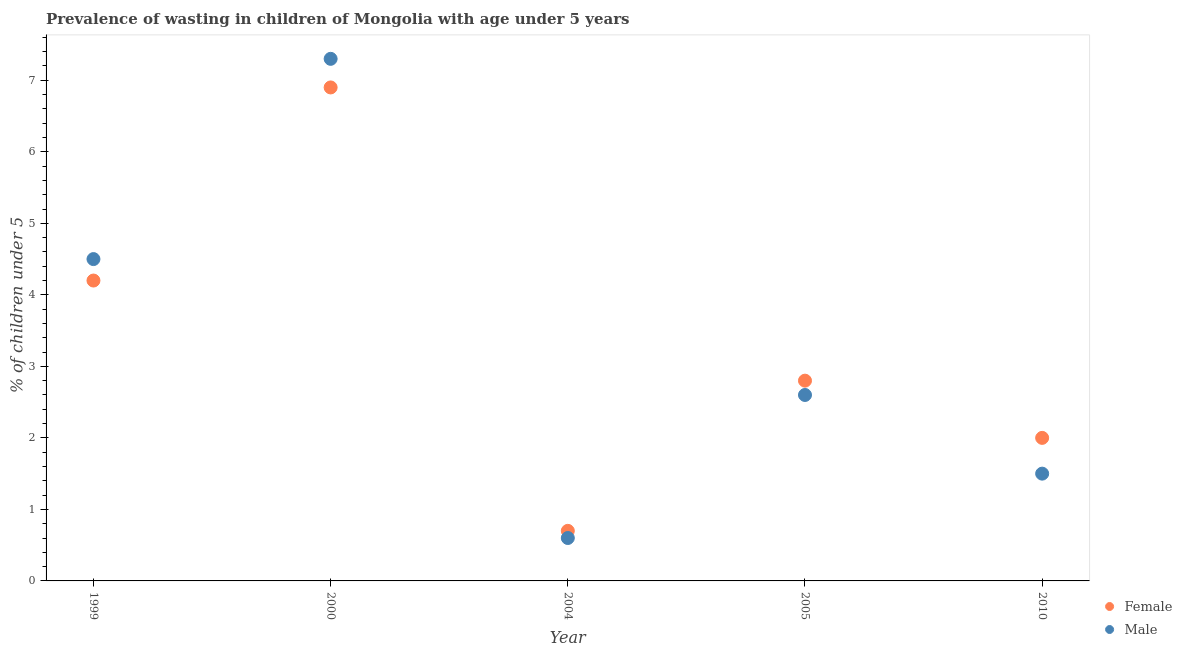Is the number of dotlines equal to the number of legend labels?
Offer a very short reply. Yes. What is the percentage of undernourished male children in 1999?
Your answer should be compact. 4.5. Across all years, what is the maximum percentage of undernourished female children?
Your response must be concise. 6.9. Across all years, what is the minimum percentage of undernourished male children?
Your answer should be very brief. 0.6. In which year was the percentage of undernourished male children minimum?
Offer a terse response. 2004. What is the total percentage of undernourished female children in the graph?
Ensure brevity in your answer.  16.6. What is the difference between the percentage of undernourished male children in 2000 and that in 2004?
Your answer should be very brief. 6.7. What is the difference between the percentage of undernourished male children in 2000 and the percentage of undernourished female children in 2005?
Make the answer very short. 4.5. What is the average percentage of undernourished male children per year?
Make the answer very short. 3.3. In the year 1999, what is the difference between the percentage of undernourished female children and percentage of undernourished male children?
Your response must be concise. -0.3. In how many years, is the percentage of undernourished male children greater than 1.6 %?
Your answer should be compact. 3. What is the ratio of the percentage of undernourished female children in 2004 to that in 2005?
Give a very brief answer. 0.25. What is the difference between the highest and the second highest percentage of undernourished female children?
Your answer should be compact. 2.7. What is the difference between the highest and the lowest percentage of undernourished male children?
Give a very brief answer. 6.7. In how many years, is the percentage of undernourished female children greater than the average percentage of undernourished female children taken over all years?
Provide a succinct answer. 2. Is the percentage of undernourished female children strictly greater than the percentage of undernourished male children over the years?
Give a very brief answer. No. Is the percentage of undernourished male children strictly less than the percentage of undernourished female children over the years?
Keep it short and to the point. No. Are the values on the major ticks of Y-axis written in scientific E-notation?
Offer a very short reply. No. Does the graph contain any zero values?
Provide a succinct answer. No. Does the graph contain grids?
Your answer should be very brief. No. How many legend labels are there?
Provide a succinct answer. 2. What is the title of the graph?
Ensure brevity in your answer.  Prevalence of wasting in children of Mongolia with age under 5 years. What is the label or title of the Y-axis?
Ensure brevity in your answer.   % of children under 5. What is the  % of children under 5 of Female in 1999?
Your response must be concise. 4.2. What is the  % of children under 5 in Female in 2000?
Make the answer very short. 6.9. What is the  % of children under 5 in Male in 2000?
Provide a short and direct response. 7.3. What is the  % of children under 5 in Female in 2004?
Provide a short and direct response. 0.7. What is the  % of children under 5 in Male in 2004?
Your answer should be compact. 0.6. What is the  % of children under 5 in Female in 2005?
Make the answer very short. 2.8. What is the  % of children under 5 of Male in 2005?
Your response must be concise. 2.6. What is the  % of children under 5 of Female in 2010?
Provide a short and direct response. 2. Across all years, what is the maximum  % of children under 5 in Female?
Offer a very short reply. 6.9. Across all years, what is the maximum  % of children under 5 in Male?
Ensure brevity in your answer.  7.3. Across all years, what is the minimum  % of children under 5 of Female?
Give a very brief answer. 0.7. Across all years, what is the minimum  % of children under 5 of Male?
Offer a terse response. 0.6. What is the total  % of children under 5 in Female in the graph?
Provide a succinct answer. 16.6. What is the total  % of children under 5 in Male in the graph?
Provide a succinct answer. 16.5. What is the difference between the  % of children under 5 in Female in 1999 and that in 2000?
Your answer should be compact. -2.7. What is the difference between the  % of children under 5 of Male in 1999 and that in 2000?
Make the answer very short. -2.8. What is the difference between the  % of children under 5 of Female in 1999 and that in 2004?
Make the answer very short. 3.5. What is the difference between the  % of children under 5 in Female in 1999 and that in 2005?
Keep it short and to the point. 1.4. What is the difference between the  % of children under 5 in Female in 1999 and that in 2010?
Offer a terse response. 2.2. What is the difference between the  % of children under 5 in Male in 1999 and that in 2010?
Your answer should be very brief. 3. What is the difference between the  % of children under 5 of Male in 2000 and that in 2004?
Provide a succinct answer. 6.7. What is the difference between the  % of children under 5 in Female in 2000 and that in 2005?
Offer a very short reply. 4.1. What is the difference between the  % of children under 5 of Female in 2000 and that in 2010?
Your response must be concise. 4.9. What is the difference between the  % of children under 5 of Male in 2000 and that in 2010?
Offer a very short reply. 5.8. What is the difference between the  % of children under 5 in Male in 2004 and that in 2005?
Offer a very short reply. -2. What is the difference between the  % of children under 5 in Female in 2004 and that in 2010?
Give a very brief answer. -1.3. What is the difference between the  % of children under 5 in Male in 2005 and that in 2010?
Your response must be concise. 1.1. What is the difference between the  % of children under 5 of Female in 1999 and the  % of children under 5 of Male in 2004?
Your answer should be compact. 3.6. What is the difference between the  % of children under 5 of Female in 1999 and the  % of children under 5 of Male in 2005?
Ensure brevity in your answer.  1.6. What is the difference between the  % of children under 5 of Female in 2000 and the  % of children under 5 of Male in 2004?
Provide a short and direct response. 6.3. What is the difference between the  % of children under 5 in Female in 2004 and the  % of children under 5 in Male in 2010?
Give a very brief answer. -0.8. What is the difference between the  % of children under 5 of Female in 2005 and the  % of children under 5 of Male in 2010?
Provide a succinct answer. 1.3. What is the average  % of children under 5 of Female per year?
Offer a very short reply. 3.32. What is the average  % of children under 5 in Male per year?
Ensure brevity in your answer.  3.3. In the year 1999, what is the difference between the  % of children under 5 of Female and  % of children under 5 of Male?
Make the answer very short. -0.3. In the year 2000, what is the difference between the  % of children under 5 in Female and  % of children under 5 in Male?
Your response must be concise. -0.4. In the year 2004, what is the difference between the  % of children under 5 in Female and  % of children under 5 in Male?
Your answer should be very brief. 0.1. In the year 2005, what is the difference between the  % of children under 5 of Female and  % of children under 5 of Male?
Your response must be concise. 0.2. What is the ratio of the  % of children under 5 in Female in 1999 to that in 2000?
Offer a terse response. 0.61. What is the ratio of the  % of children under 5 of Male in 1999 to that in 2000?
Make the answer very short. 0.62. What is the ratio of the  % of children under 5 of Female in 1999 to that in 2004?
Your answer should be compact. 6. What is the ratio of the  % of children under 5 in Male in 1999 to that in 2004?
Provide a succinct answer. 7.5. What is the ratio of the  % of children under 5 of Male in 1999 to that in 2005?
Your response must be concise. 1.73. What is the ratio of the  % of children under 5 in Female in 1999 to that in 2010?
Keep it short and to the point. 2.1. What is the ratio of the  % of children under 5 in Female in 2000 to that in 2004?
Keep it short and to the point. 9.86. What is the ratio of the  % of children under 5 in Male in 2000 to that in 2004?
Make the answer very short. 12.17. What is the ratio of the  % of children under 5 of Female in 2000 to that in 2005?
Offer a very short reply. 2.46. What is the ratio of the  % of children under 5 of Male in 2000 to that in 2005?
Ensure brevity in your answer.  2.81. What is the ratio of the  % of children under 5 in Female in 2000 to that in 2010?
Your answer should be compact. 3.45. What is the ratio of the  % of children under 5 of Male in 2000 to that in 2010?
Provide a short and direct response. 4.87. What is the ratio of the  % of children under 5 of Male in 2004 to that in 2005?
Your answer should be very brief. 0.23. What is the ratio of the  % of children under 5 in Female in 2004 to that in 2010?
Give a very brief answer. 0.35. What is the ratio of the  % of children under 5 of Male in 2005 to that in 2010?
Make the answer very short. 1.73. What is the difference between the highest and the second highest  % of children under 5 in Male?
Offer a terse response. 2.8. What is the difference between the highest and the lowest  % of children under 5 in Female?
Offer a terse response. 6.2. What is the difference between the highest and the lowest  % of children under 5 in Male?
Keep it short and to the point. 6.7. 